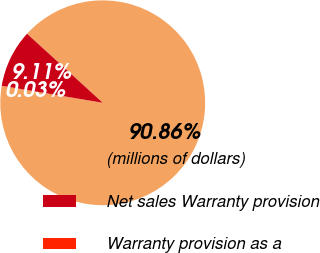Convert chart to OTSL. <chart><loc_0><loc_0><loc_500><loc_500><pie_chart><fcel>(millions of dollars)<fcel>Net sales Warranty provision<fcel>Warranty provision as a<nl><fcel>90.86%<fcel>9.11%<fcel>0.03%<nl></chart> 